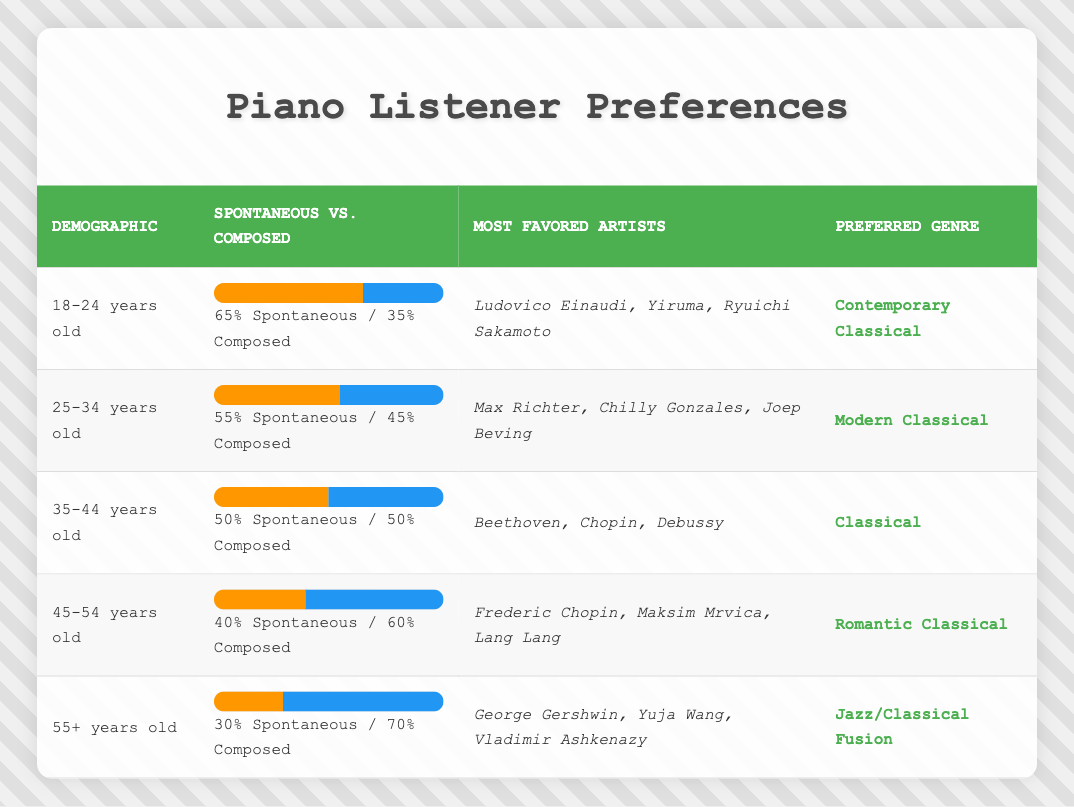What percentage of listeners aged 45-54 favor spontaneous piano pieces? According to the table, the percentage of spontaneous piano pieces for the demographic aged 45-54 is 40%.
Answer: 40% Which demographic has the highest preference for spontaneous piano pieces? The table shows that the demographic aged 18-24 has the highest percentage of spontaneous piano pieces at 65%.
Answer: 18-24 years old Is it true that listeners aged 55 and older prefer composed piano pieces over spontaneous ones? Yes, the table indicates that listeners aged 55+ have a preference of 70% for composed piano pieces compared to 30% for spontaneous pieces, confirming they favor composed works.
Answer: Yes What is the average percentage of spontaneous piano piece preferences across all demographics? Calculating the average involves adding the percentages (65 + 55 + 50 + 40 + 30 = 240) and dividing by the number of demographics (5). Therefore, the average percentage is 240 / 5 = 48%.
Answer: 48% Which favored artists are listed for the demographic aged 35-44? The table specifies the most favored artists for the 35-44 age group as Beethoven, Chopin, and Debussy.
Answer: Beethoven, Chopin, Debussy What is the difference in preference for spontaneous piano pieces between the 18-24 and 25-34 age groups? The 18-24 age group has a preference of 65% for spontaneous pieces, while the 25-34 age group has 55%. The difference is 65% - 55% = 10%.
Answer: 10% Do listeners aged 45-54 have more preference for composed pieces or spontaneous pieces? The table shows that 60% of listeners aged 45-54 prefer composed pieces compared to 40% for spontaneous pieces, indicating they prefer composed pieces.
Answer: Composed pieces Which genre is preferred by listeners aged 55 and older? According to the table, the preferred genre for listeners aged 55+ is Jazz/Classical Fusion.
Answer: Jazz/Classical Fusion What percentage of listeners aged 25-34 prefer composed piano pieces? The table indicates that the percentage for composed piano pieces among the 25-34 age group is 45%.
Answer: 45% 